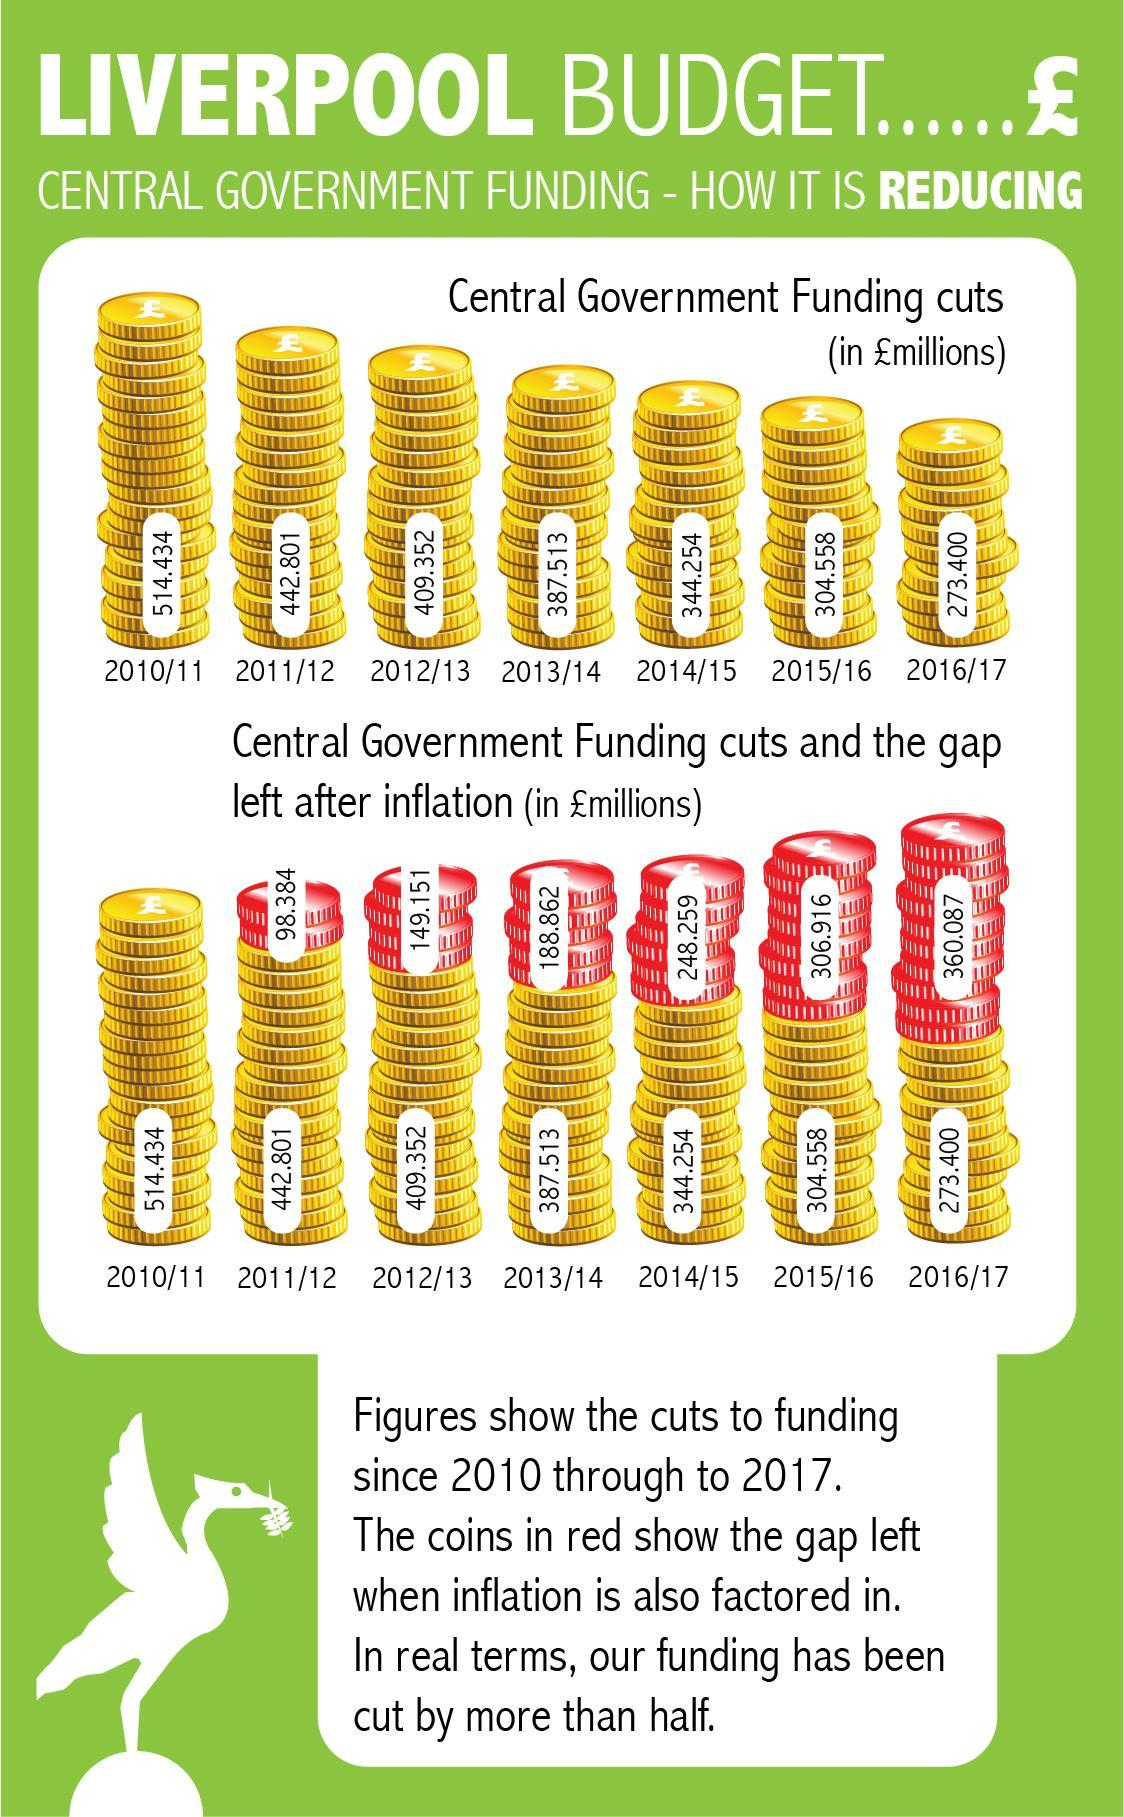During which fiscal year did central government cut funding by 304.558 million?
Answer the question with a short phrase. 2015/16 The gap left after inflation from 2011/12 to 2016/17 is - increasing or reducing? increasing During which fiscal year was there a gap of 98.384 million pounds? 2011/12 In which fiscal year is the highest gap after inflation shown? 2016/17 For which fiscal year there is no gap after inflation shown? 2010/11 In which fiscal year is the smallest gap after inflation shown? 2011/12 